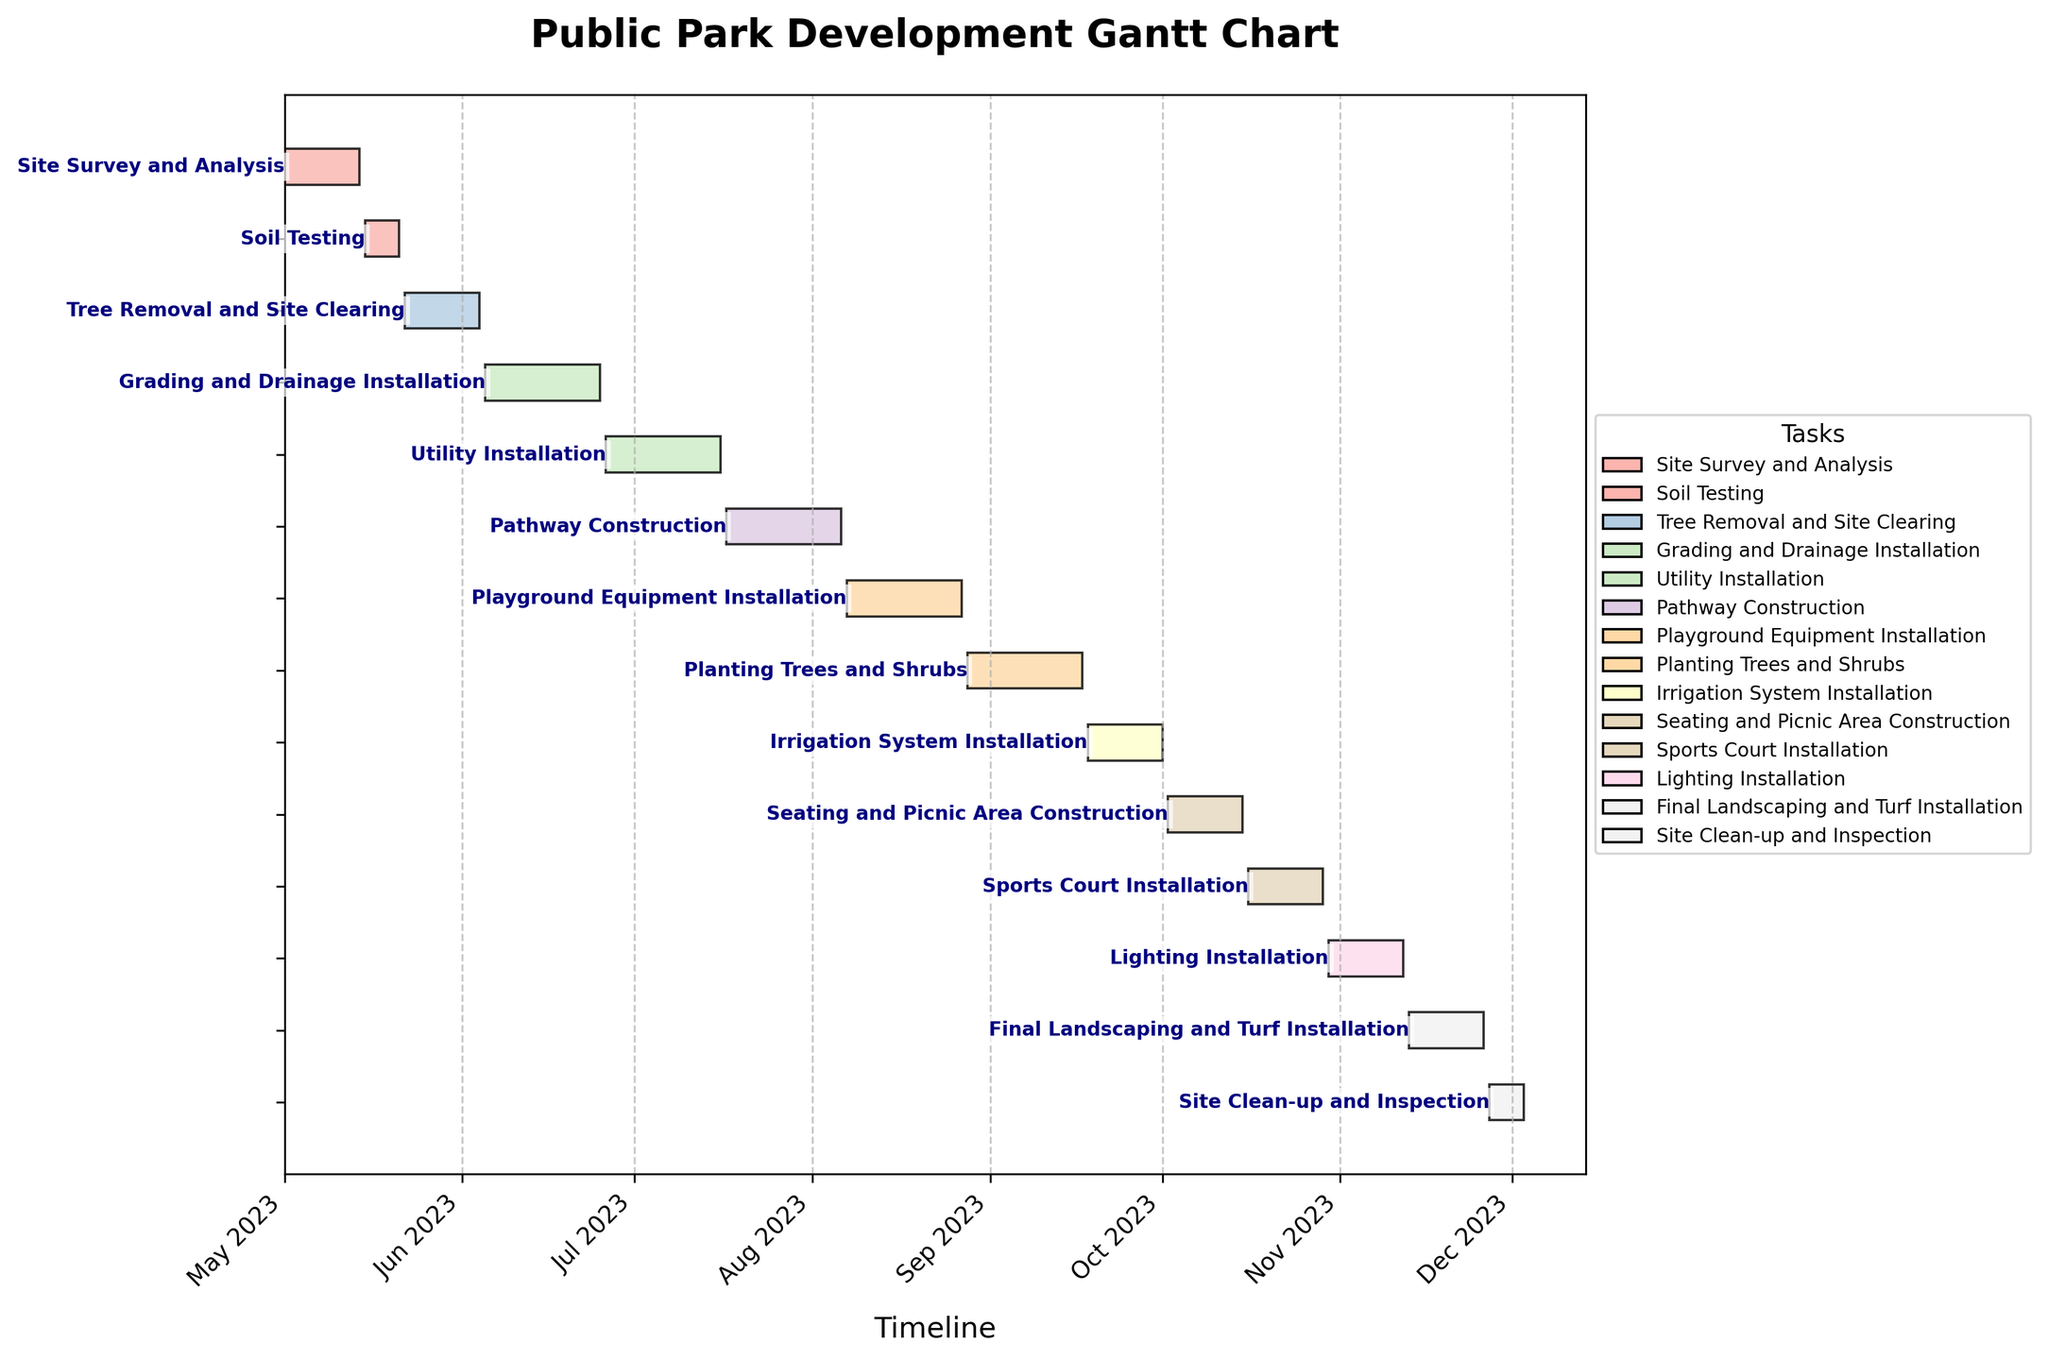What is the first task in the construction schedule? The first bar on the Gantt chart represents the earliest task, which is positioned on the topmost row. This task is labeled on the right side of the bar.
Answer: Site Survey and Analysis Which task has the shortest duration? By examining the lengths of all bars on the Gantt chart, we can identify the shortest one. The duration of each task is proportional to the length of its corresponding bar.
Answer: Soil Testing and Site Clean-up and Inspection How many tasks are scheduled to be completed by the end of September 2023? By counting the number of tasks that end by September 30th on the x-axis, we can determine which tasks fit this criterion.
Answer: 7 Which task will overlap with the installation of the irrigation system? We need to verify which tasks have date ranges that intersect with the dates of the Irrigation System Installation (Sep 18 – Oct 01, 2023).
Answer: Planting Trees and Shrubs What is the total duration of the Grading and Drainage Installation and Utility Installation tasks combined? First, find the duration of each task on the chart. Grading and Drainage Installation is 21 days and Utility Installation is also 21 days. Summing them, we get 21 + 21.
Answer: 42 days How many tasks have a duration longer than 14 days? From the Gantt chart, count all tasks where the length of the bar exceeds the length representing 14 days.
Answer: 8 Which two tasks have the exact same duration and what is that duration? By comparing the lengths of all the bars, we identify which two bars are of identical lengths and read the corresponding durations and task labels.
Answer: Site Survey and Analysis, Irrigation System Installation, Seating and Picnic Area Construction, Sports Court Installation, Lighting Installation, Final Landscaping and Turf Installation. Duration: 14 days Which task lasts through the entirety of July 2023? Find the task bar that starts before July 1st and ends after July 31st, 2023, ensuring it spans the entire month of July.
Answer: Utility Installation What is the total duration of tasks scheduled after the completion of the Playground Equipment Installation? Tasks after Playground Equipment Installation (ending August 27th) include Planting Trees and Shrubs (21 days), Irrigation System Installation (14 days), Seating and Picnic Area Construction (14 days), Sports Court Installation (14 days), Lighting Installation (14 days), Final Landscaping and Turf Installation (14 days), and Site Clean-up and Inspection (7 days). Summing these, we get 21+14+14+14+14+14+7.
Answer: 98 days 